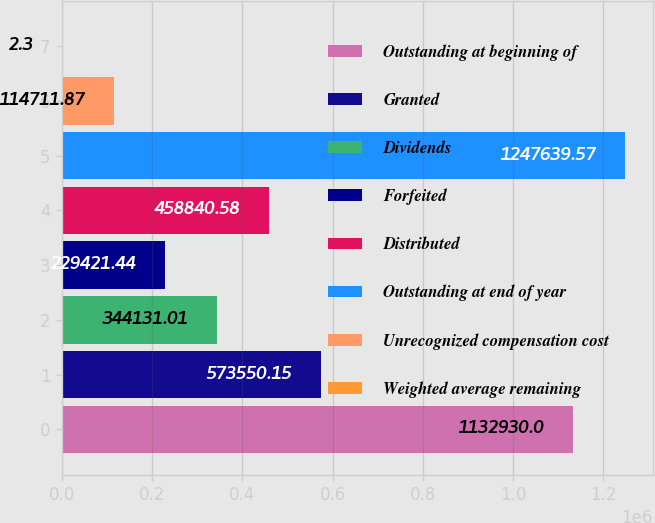Convert chart. <chart><loc_0><loc_0><loc_500><loc_500><bar_chart><fcel>Outstanding at beginning of<fcel>Granted<fcel>Dividends<fcel>Forfeited<fcel>Distributed<fcel>Outstanding at end of year<fcel>Unrecognized compensation cost<fcel>Weighted average remaining<nl><fcel>1.13293e+06<fcel>573550<fcel>344131<fcel>229421<fcel>458841<fcel>1.24764e+06<fcel>114712<fcel>2.3<nl></chart> 